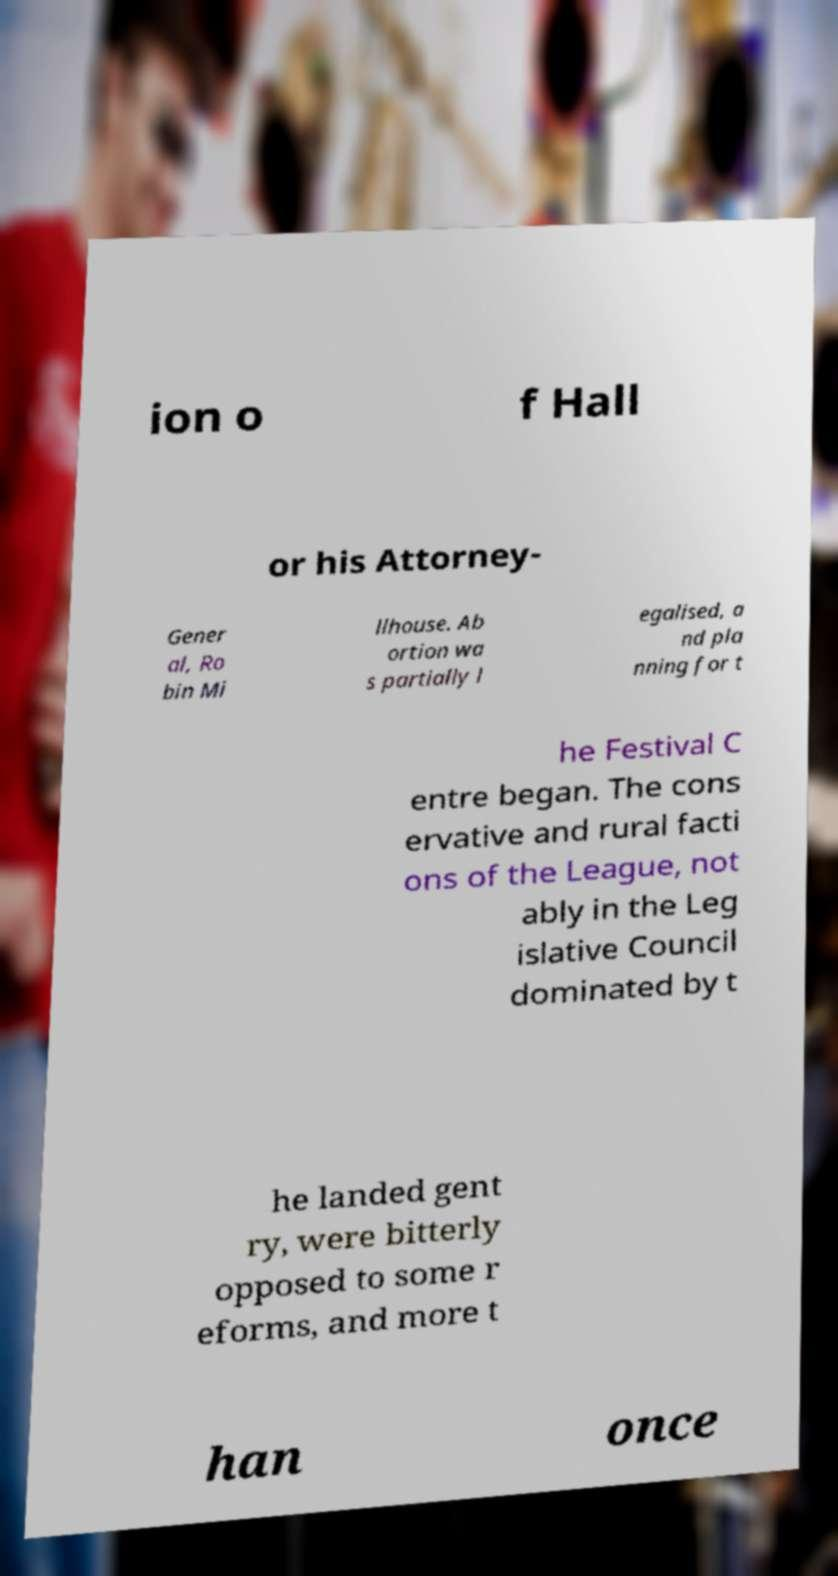Can you accurately transcribe the text from the provided image for me? ion o f Hall or his Attorney- Gener al, Ro bin Mi llhouse. Ab ortion wa s partially l egalised, a nd pla nning for t he Festival C entre began. The cons ervative and rural facti ons of the League, not ably in the Leg islative Council dominated by t he landed gent ry, were bitterly opposed to some r eforms, and more t han once 